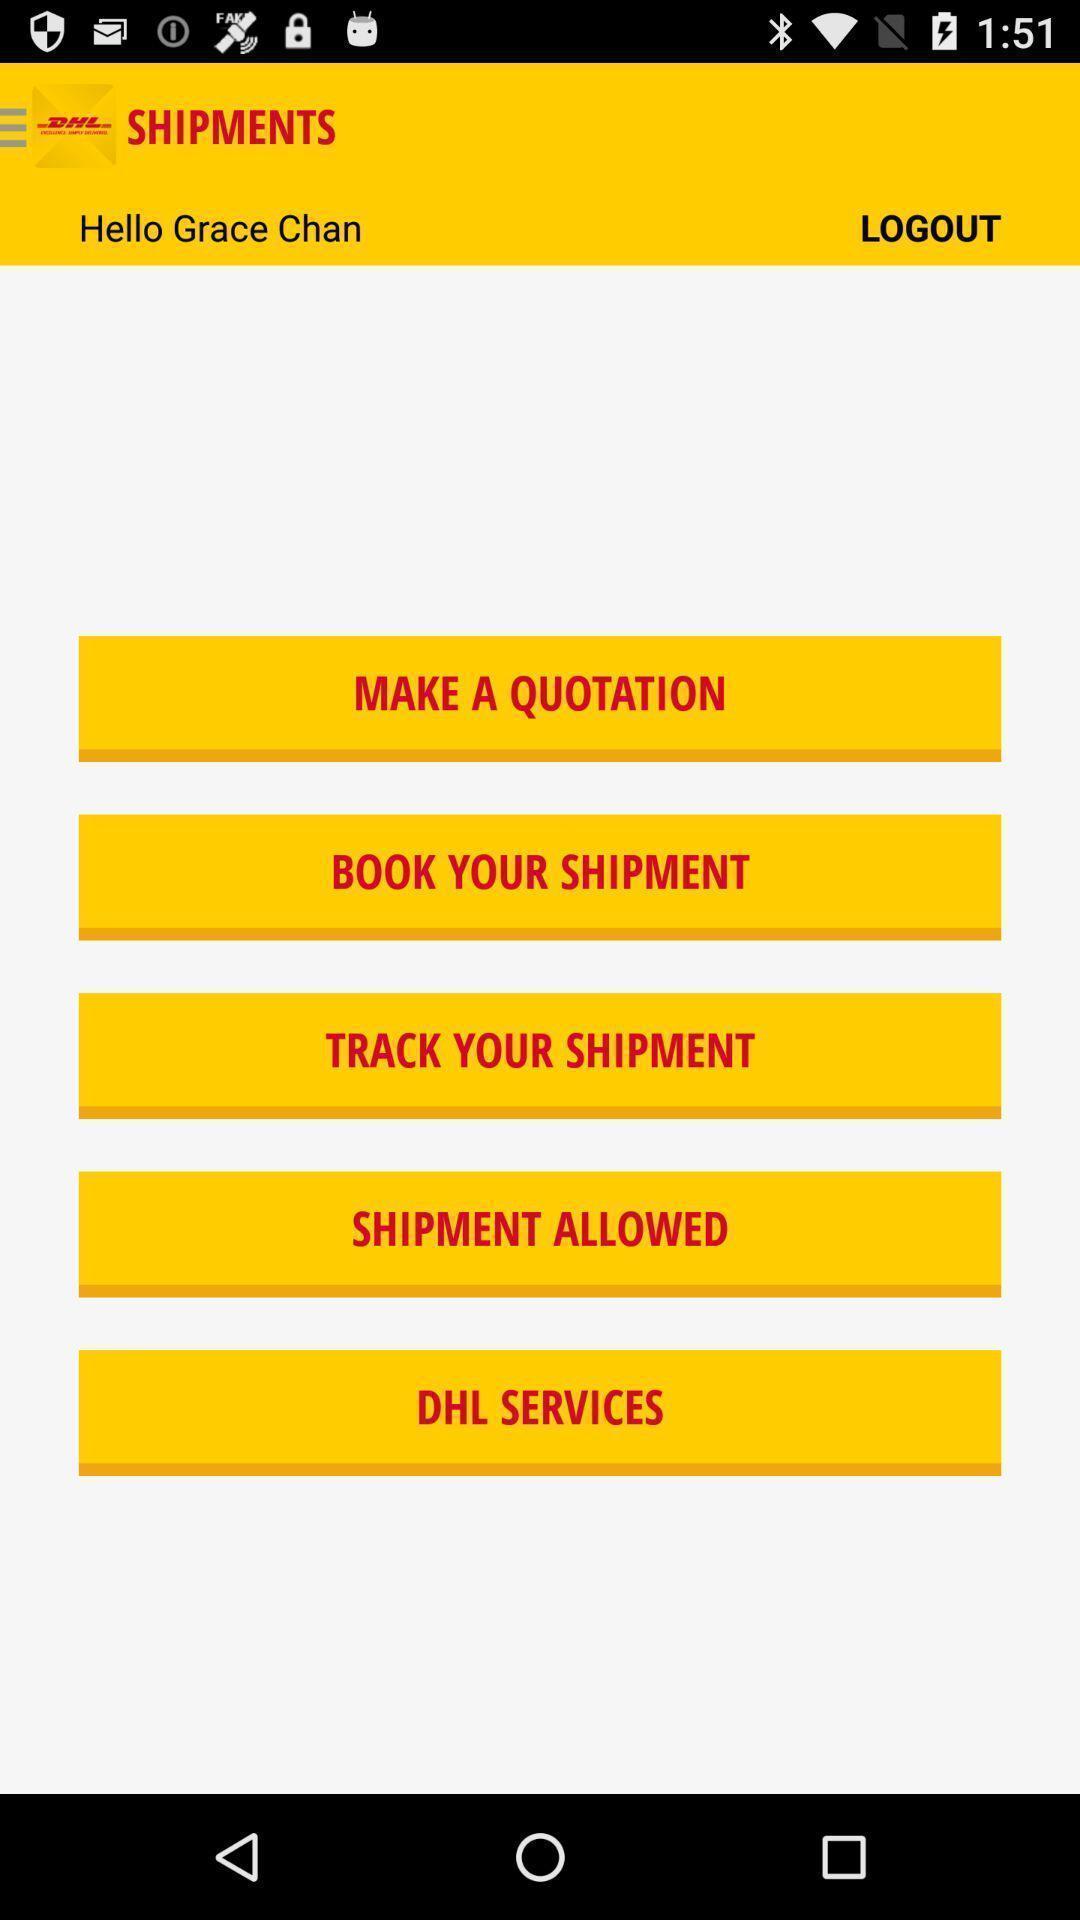Tell me what you see in this picture. Screen shows list of options in shipments tracking app. 